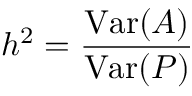Convert formula to latex. <formula><loc_0><loc_0><loc_500><loc_500>h ^ { 2 } = { \frac { V a r ( A ) } { V a r ( P ) } }</formula> 